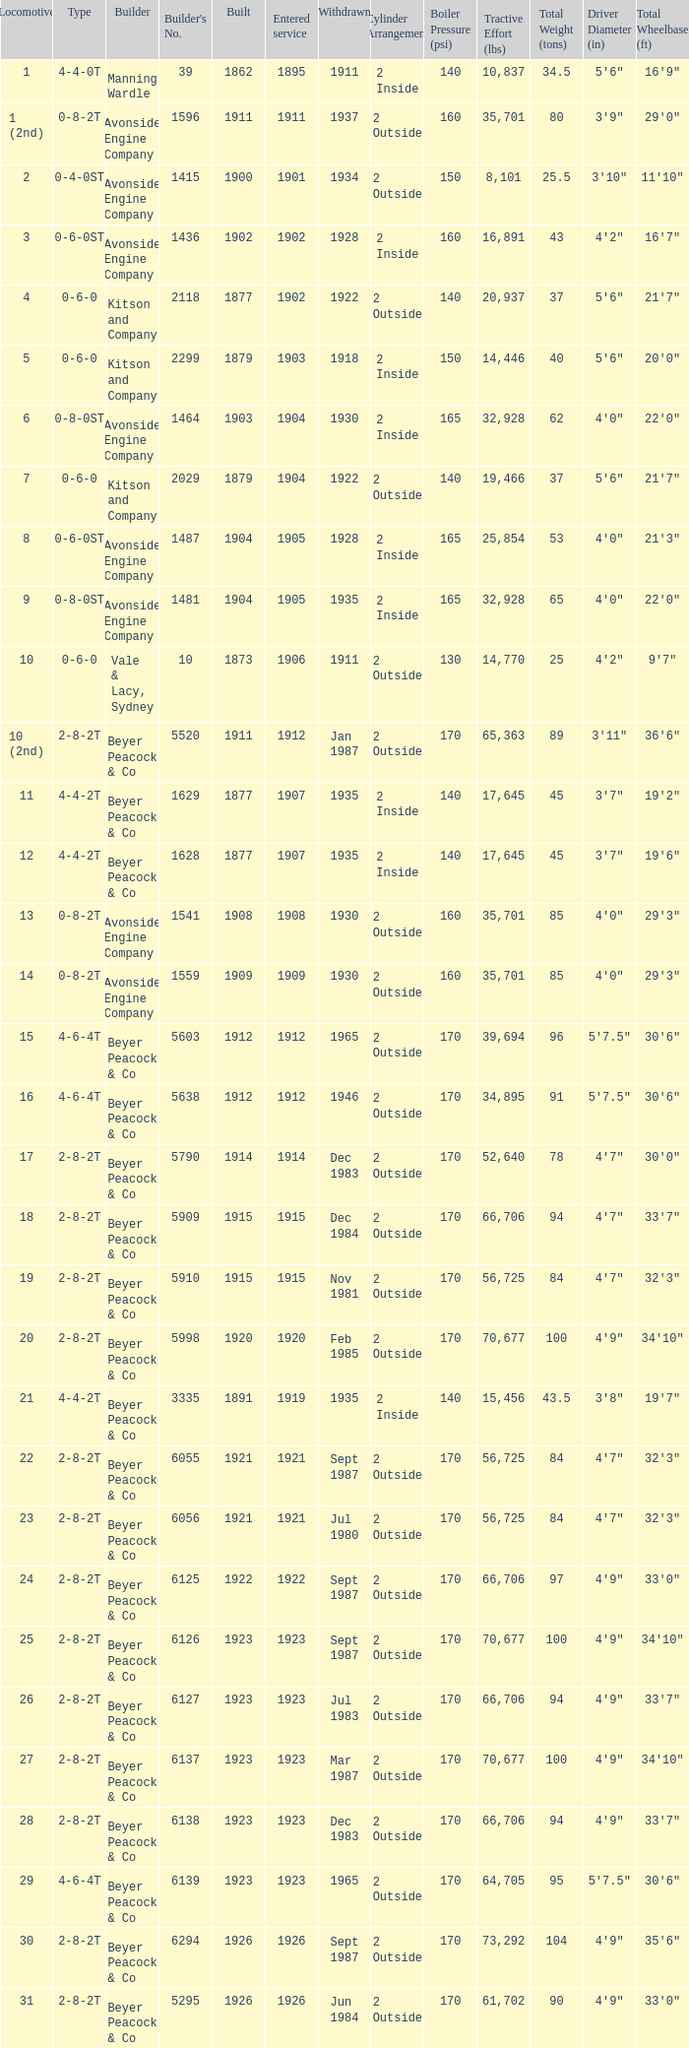Which locomotive had a 2-8-2t type, entered service year prior to 1915, and which was built after 1911? 17.0. 